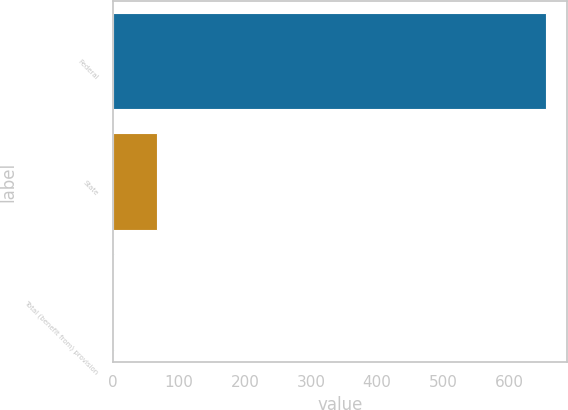<chart> <loc_0><loc_0><loc_500><loc_500><bar_chart><fcel>Federal<fcel>State<fcel>Total (benefit from) provision<nl><fcel>655.1<fcel>67.13<fcel>1.8<nl></chart> 